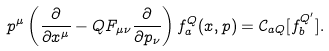<formula> <loc_0><loc_0><loc_500><loc_500>p ^ { \mu } \left ( \frac { \partial } { \partial x ^ { \mu } } - Q F _ { \mu \nu } \frac { \partial } { \partial p _ { \nu } } \right ) f _ { a } ^ { Q } ( x , p ) = \mathcal { C } _ { a Q } [ f _ { b } ^ { Q ^ { \prime } } ] .</formula> 